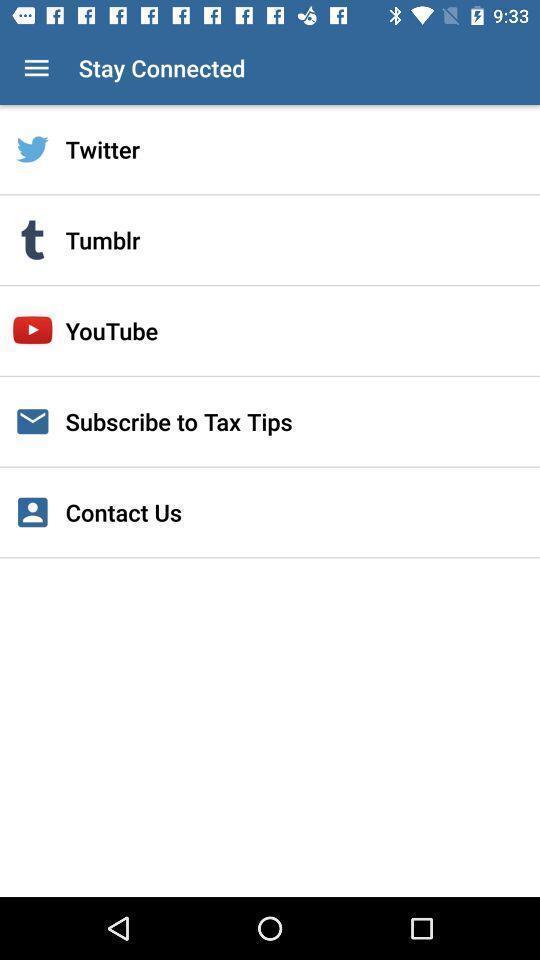Please provide a description for this image. Various social media apps displayed to stay connect. 